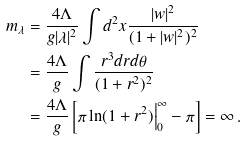Convert formula to latex. <formula><loc_0><loc_0><loc_500><loc_500>m _ { \lambda } & = \frac { 4 \Lambda } { g | \lambda | ^ { 2 } } \int d ^ { 2 } x \frac { | w | ^ { 2 } } { ( 1 + | w | ^ { 2 } ) ^ { 2 } } \\ & = \frac { 4 \Lambda } { g } \int \frac { r ^ { 3 } d r d \theta } { ( 1 + r ^ { 2 } ) ^ { 2 } } \\ & = \frac { 4 \Lambda } { g } \left [ \pi \ln ( 1 + r ^ { 2 } ) \Big | _ { 0 } ^ { \infty } - \pi \right ] = \infty \, .</formula> 